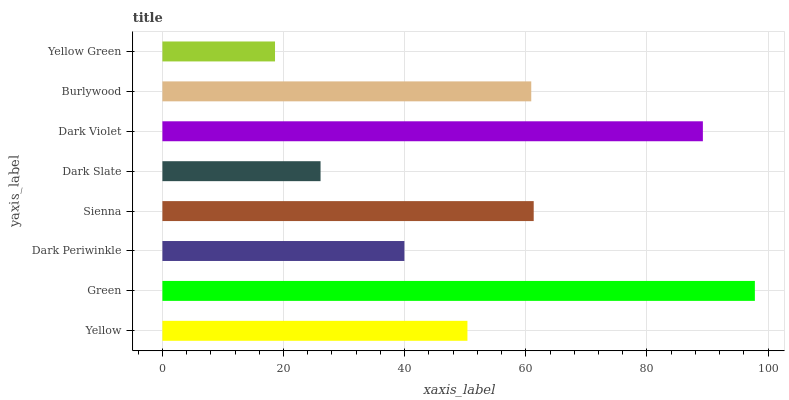Is Yellow Green the minimum?
Answer yes or no. Yes. Is Green the maximum?
Answer yes or no. Yes. Is Dark Periwinkle the minimum?
Answer yes or no. No. Is Dark Periwinkle the maximum?
Answer yes or no. No. Is Green greater than Dark Periwinkle?
Answer yes or no. Yes. Is Dark Periwinkle less than Green?
Answer yes or no. Yes. Is Dark Periwinkle greater than Green?
Answer yes or no. No. Is Green less than Dark Periwinkle?
Answer yes or no. No. Is Burlywood the high median?
Answer yes or no. Yes. Is Yellow the low median?
Answer yes or no. Yes. Is Dark Periwinkle the high median?
Answer yes or no. No. Is Dark Violet the low median?
Answer yes or no. No. 